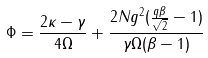<formula> <loc_0><loc_0><loc_500><loc_500>\Phi = \frac { 2 \kappa - \gamma } { 4 \Omega } + \frac { 2 N g ^ { 2 } ( \frac { q \beta } { \sqrt { 2 } } - 1 ) } { \gamma \Omega ( \beta - 1 ) }</formula> 